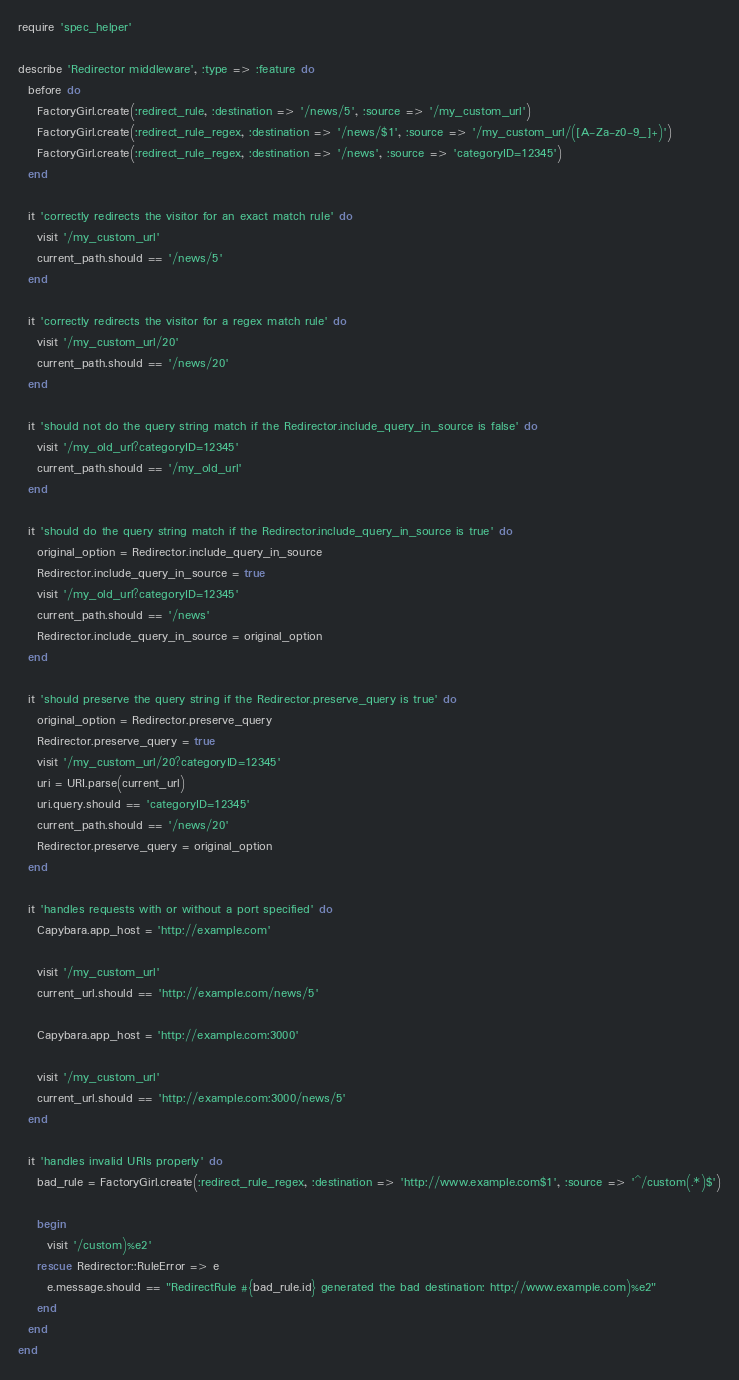<code> <loc_0><loc_0><loc_500><loc_500><_Ruby_>require 'spec_helper'

describe 'Redirector middleware', :type => :feature do
  before do
    FactoryGirl.create(:redirect_rule, :destination => '/news/5', :source => '/my_custom_url')
    FactoryGirl.create(:redirect_rule_regex, :destination => '/news/$1', :source => '/my_custom_url/([A-Za-z0-9_]+)')
    FactoryGirl.create(:redirect_rule_regex, :destination => '/news', :source => 'categoryID=12345')
  end

  it 'correctly redirects the visitor for an exact match rule' do
    visit '/my_custom_url'
    current_path.should == '/news/5'
  end

  it 'correctly redirects the visitor for a regex match rule' do
    visit '/my_custom_url/20'
    current_path.should == '/news/20'
  end

  it 'should not do the query string match if the Redirector.include_query_in_source is false' do
    visit '/my_old_url?categoryID=12345'
    current_path.should == '/my_old_url'
  end

  it 'should do the query string match if the Redirector.include_query_in_source is true' do
    original_option = Redirector.include_query_in_source
    Redirector.include_query_in_source = true
    visit '/my_old_url?categoryID=12345'
    current_path.should == '/news'
    Redirector.include_query_in_source = original_option
  end

  it 'should preserve the query string if the Redirector.preserve_query is true' do
    original_option = Redirector.preserve_query
    Redirector.preserve_query = true
    visit '/my_custom_url/20?categoryID=12345'
    uri = URI.parse(current_url)
    uri.query.should == 'categoryID=12345'
    current_path.should == '/news/20'
    Redirector.preserve_query = original_option
  end

  it 'handles requests with or without a port specified' do
    Capybara.app_host = 'http://example.com'

    visit '/my_custom_url'
    current_url.should == 'http://example.com/news/5'

    Capybara.app_host = 'http://example.com:3000'

    visit '/my_custom_url'
    current_url.should == 'http://example.com:3000/news/5'
  end

  it 'handles invalid URIs properly' do
    bad_rule = FactoryGirl.create(:redirect_rule_regex, :destination => 'http://www.example.com$1', :source => '^/custom(.*)$')

    begin
      visit '/custom)%e2'
    rescue Redirector::RuleError => e
      e.message.should == "RedirectRule #{bad_rule.id} generated the bad destination: http://www.example.com)%e2"
    end
  end
end
</code> 